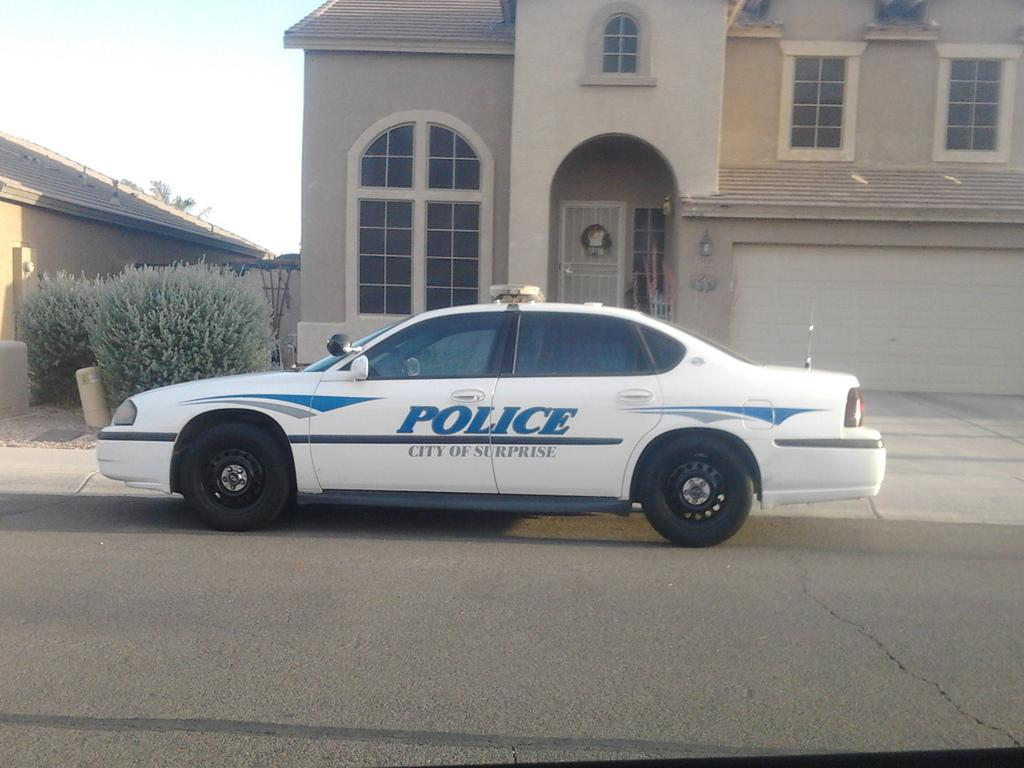What is the main subject of the image? The main subject of the image is a car. Where is the car located in the image? The car is on the road in the image. What can be seen in the background of the image? There is a house and plants in the background of the image. Can you describe any specific features of the car? There is a door visible in the image, which suggests that the car has at least one door. What type of sail can be seen on the car in the image? There is no sail present on the car in the image; it is a regular car on the road. 